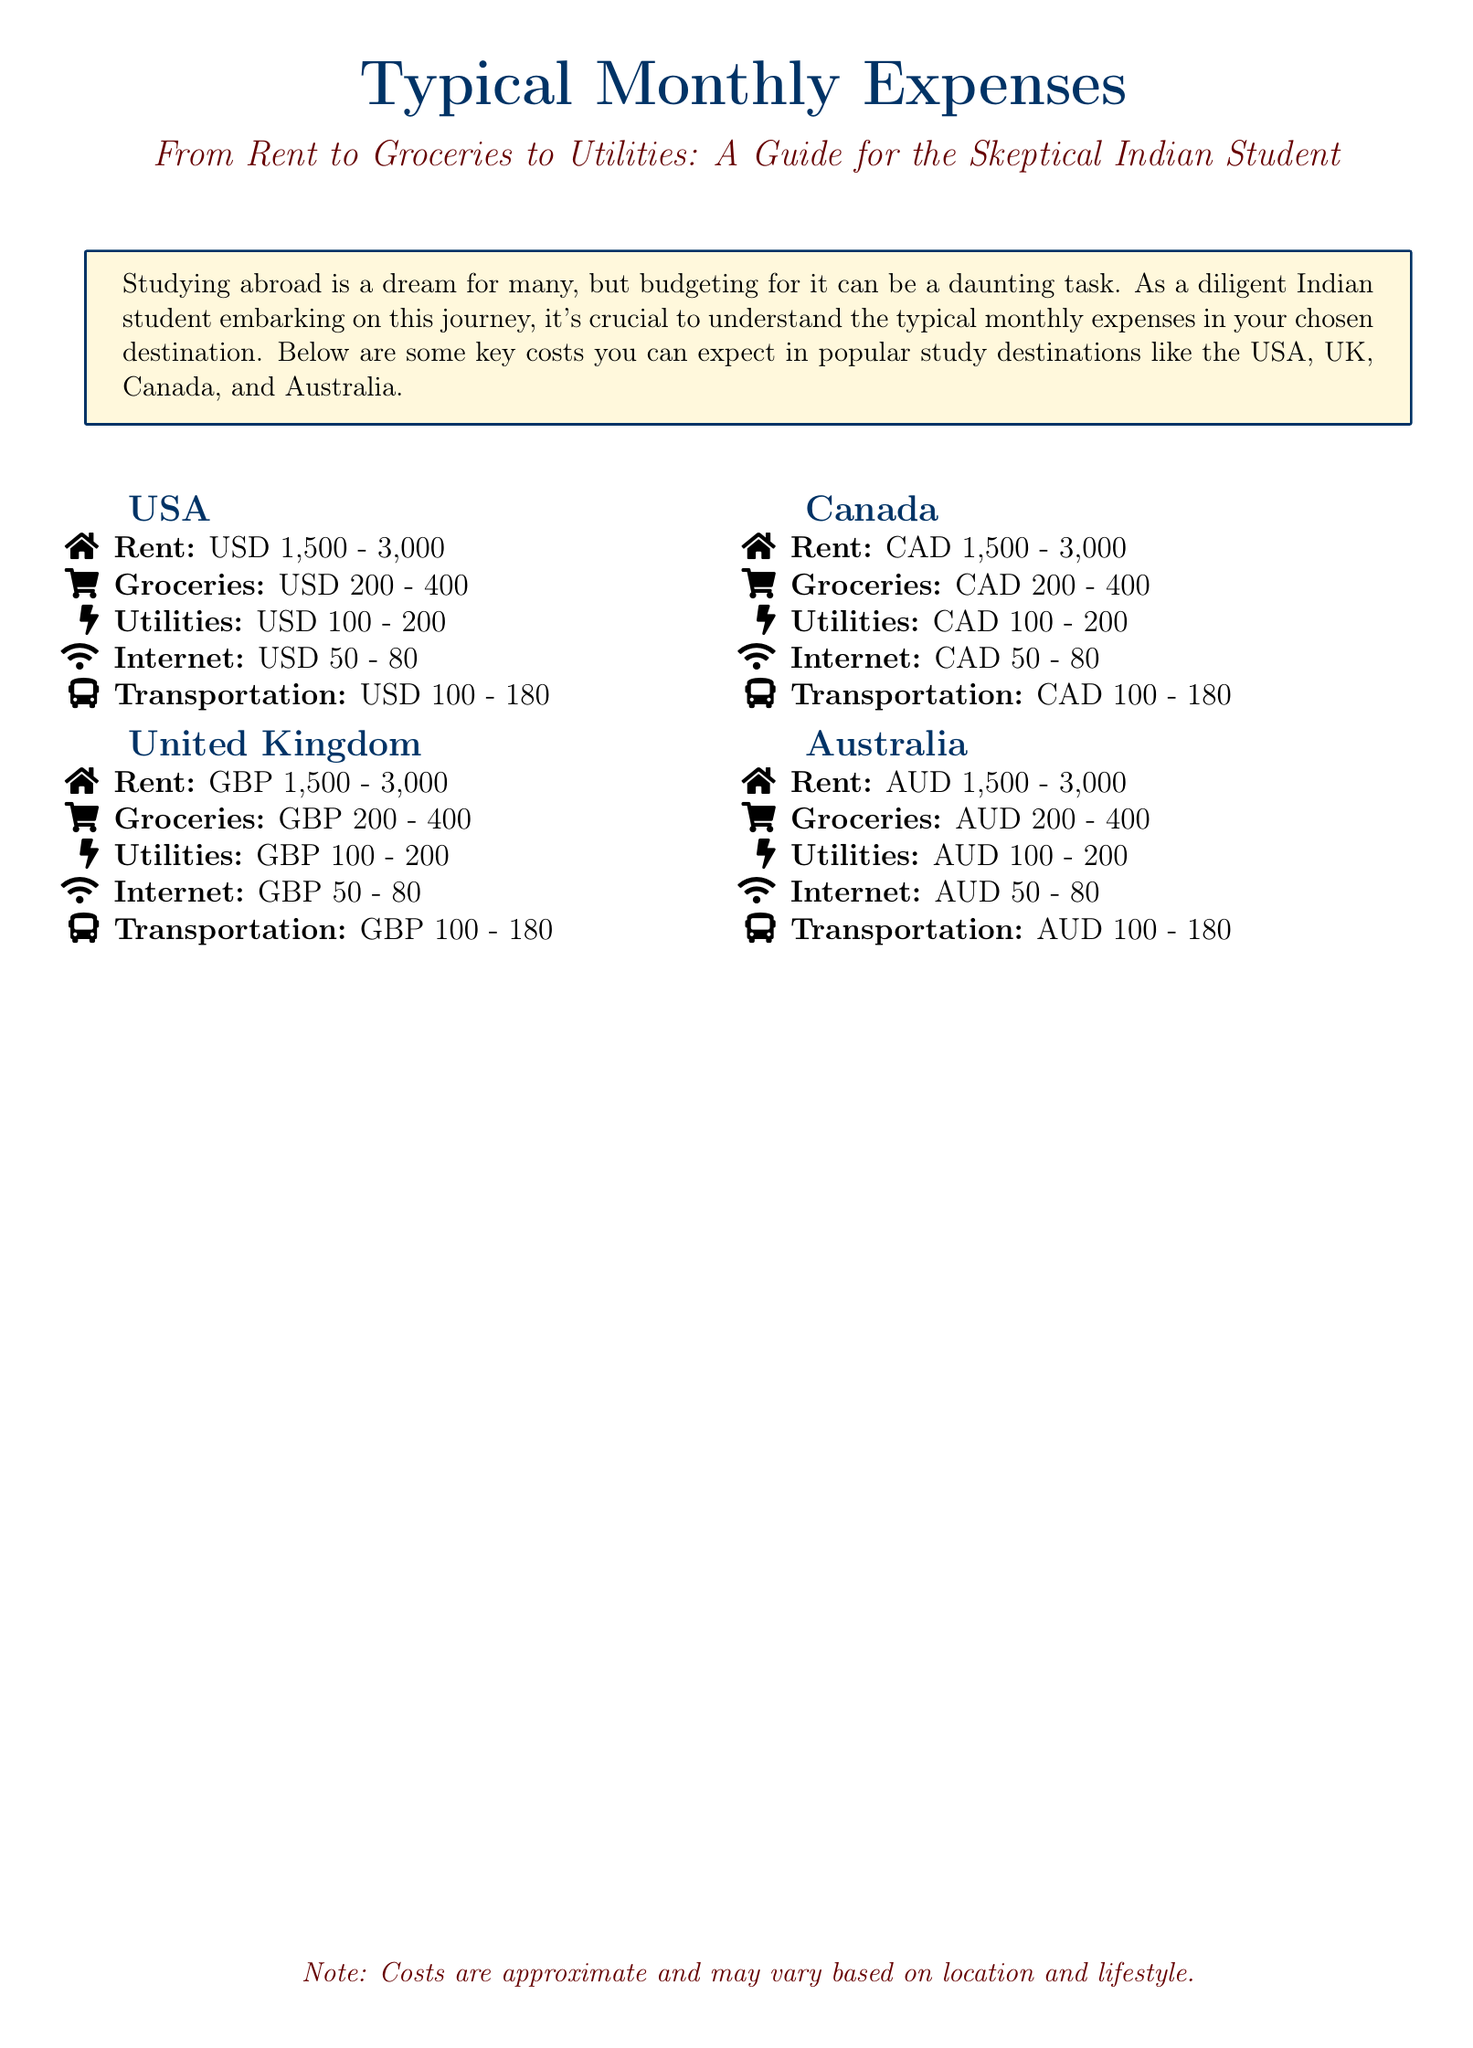what is the estimated rent range in the USA? The document lists the rent range for the USA as 1,500 to 3,000 USD.
Answer: 1,500 - 3,000 what currency is used in the United Kingdom? The document specifies that the currency used in the United Kingdom is GBP.
Answer: GBP how much can one expect to pay for groceries in Canada? According to the document, groceries in Canada typically cost between 200 to 400 CAD.
Answer: 200 - 400 what are the typical utility expenses in Australia? The document indicates that utilities in Australia range from 100 to 200 AUD.
Answer: 100 - 200 which study destination has the highest estimated transportation cost? The cost for transportation in the USA is at the higher end compared to other countries, with a range of 100 to 180 USD.
Answer: USA what is the approximate cost range for internet in the UK? The document notes that internet costs in the UK range between 50 to 80 GBP.
Answer: 50 - 80 how many total expenses categories are listed for each country? The document provides information on five expense categories for each country: Rent, Groceries, Utilities, Internet, Transportation.
Answer: Five which country's expenses include a range of 100 to 180 for transportation? The USA's transportation cost range is documented as 100 to 180 USD.
Answer: USA what is the overall purpose of the document? The document aims to guide students in understanding typical monthly expenses while studying abroad.
Answer: Budgeting for studying abroad 